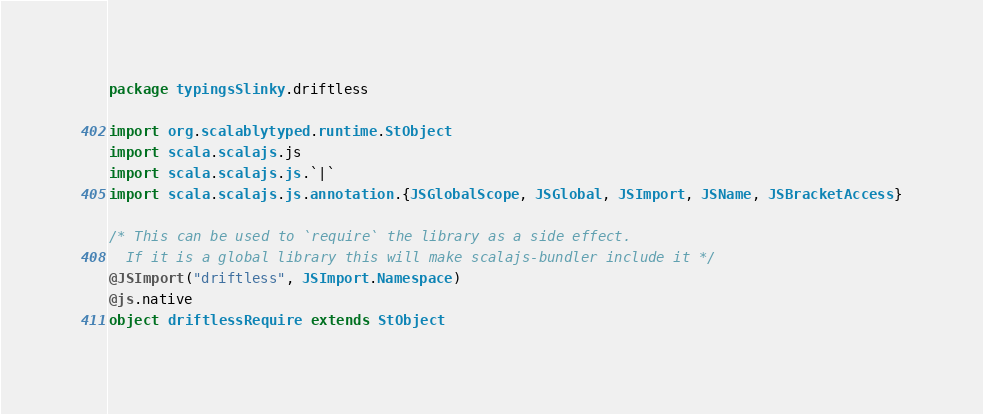<code> <loc_0><loc_0><loc_500><loc_500><_Scala_>package typingsSlinky.driftless

import org.scalablytyped.runtime.StObject
import scala.scalajs.js
import scala.scalajs.js.`|`
import scala.scalajs.js.annotation.{JSGlobalScope, JSGlobal, JSImport, JSName, JSBracketAccess}

/* This can be used to `require` the library as a side effect.
  If it is a global library this will make scalajs-bundler include it */
@JSImport("driftless", JSImport.Namespace)
@js.native
object driftlessRequire extends StObject
</code> 